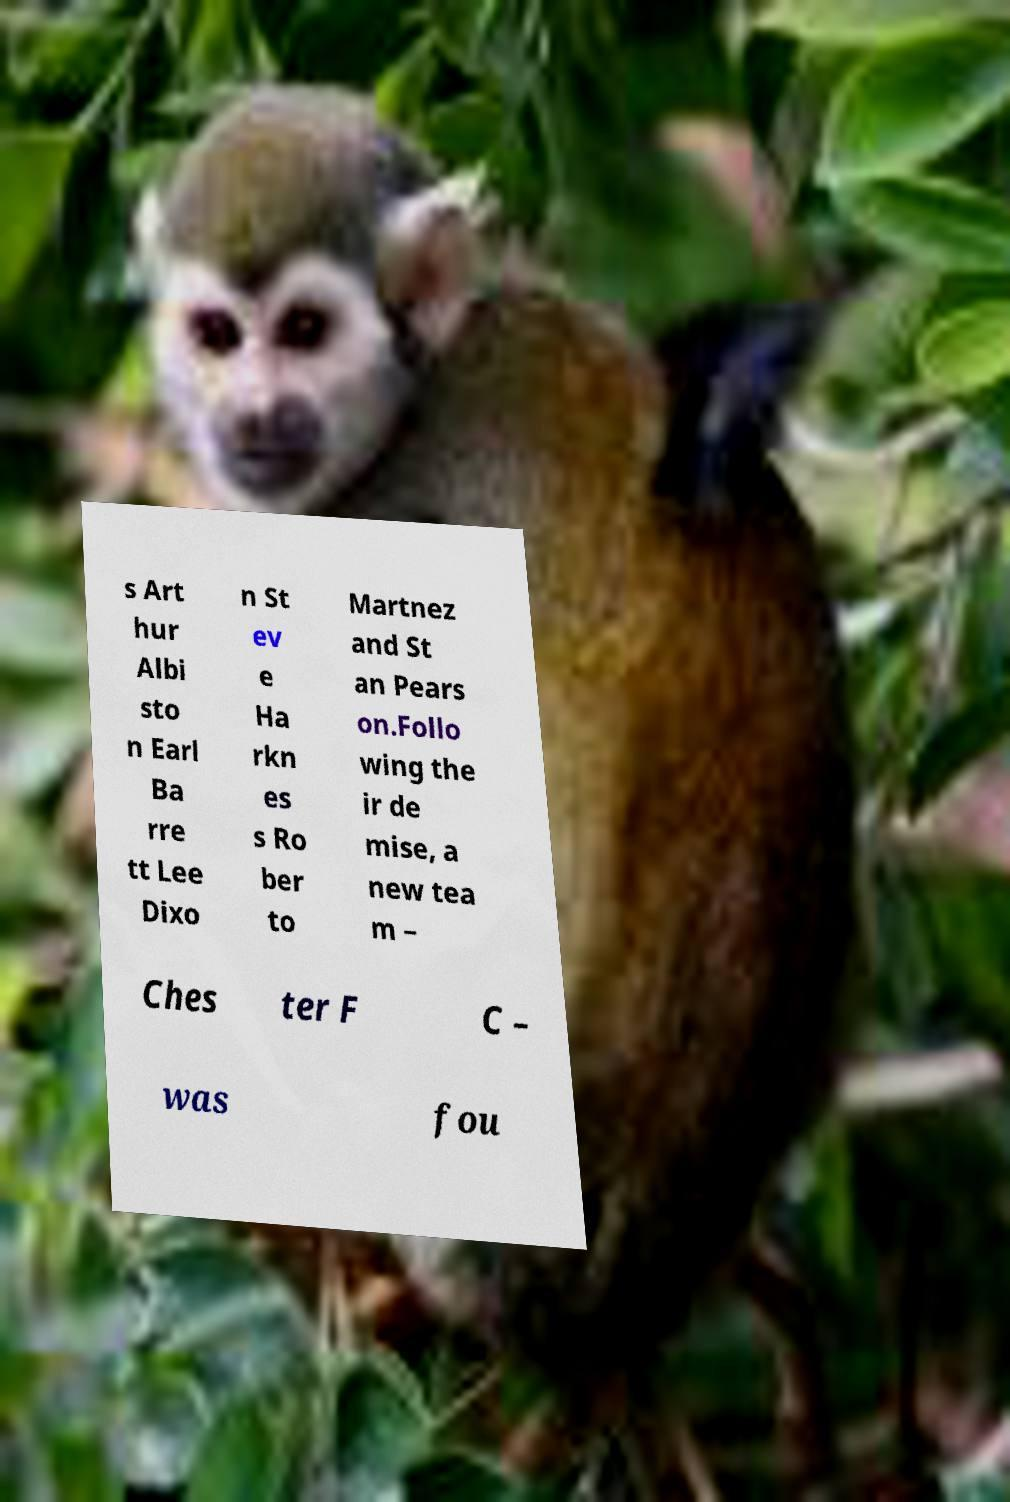Could you extract and type out the text from this image? s Art hur Albi sto n Earl Ba rre tt Lee Dixo n St ev e Ha rkn es s Ro ber to Martnez and St an Pears on.Follo wing the ir de mise, a new tea m – Ches ter F C – was fou 